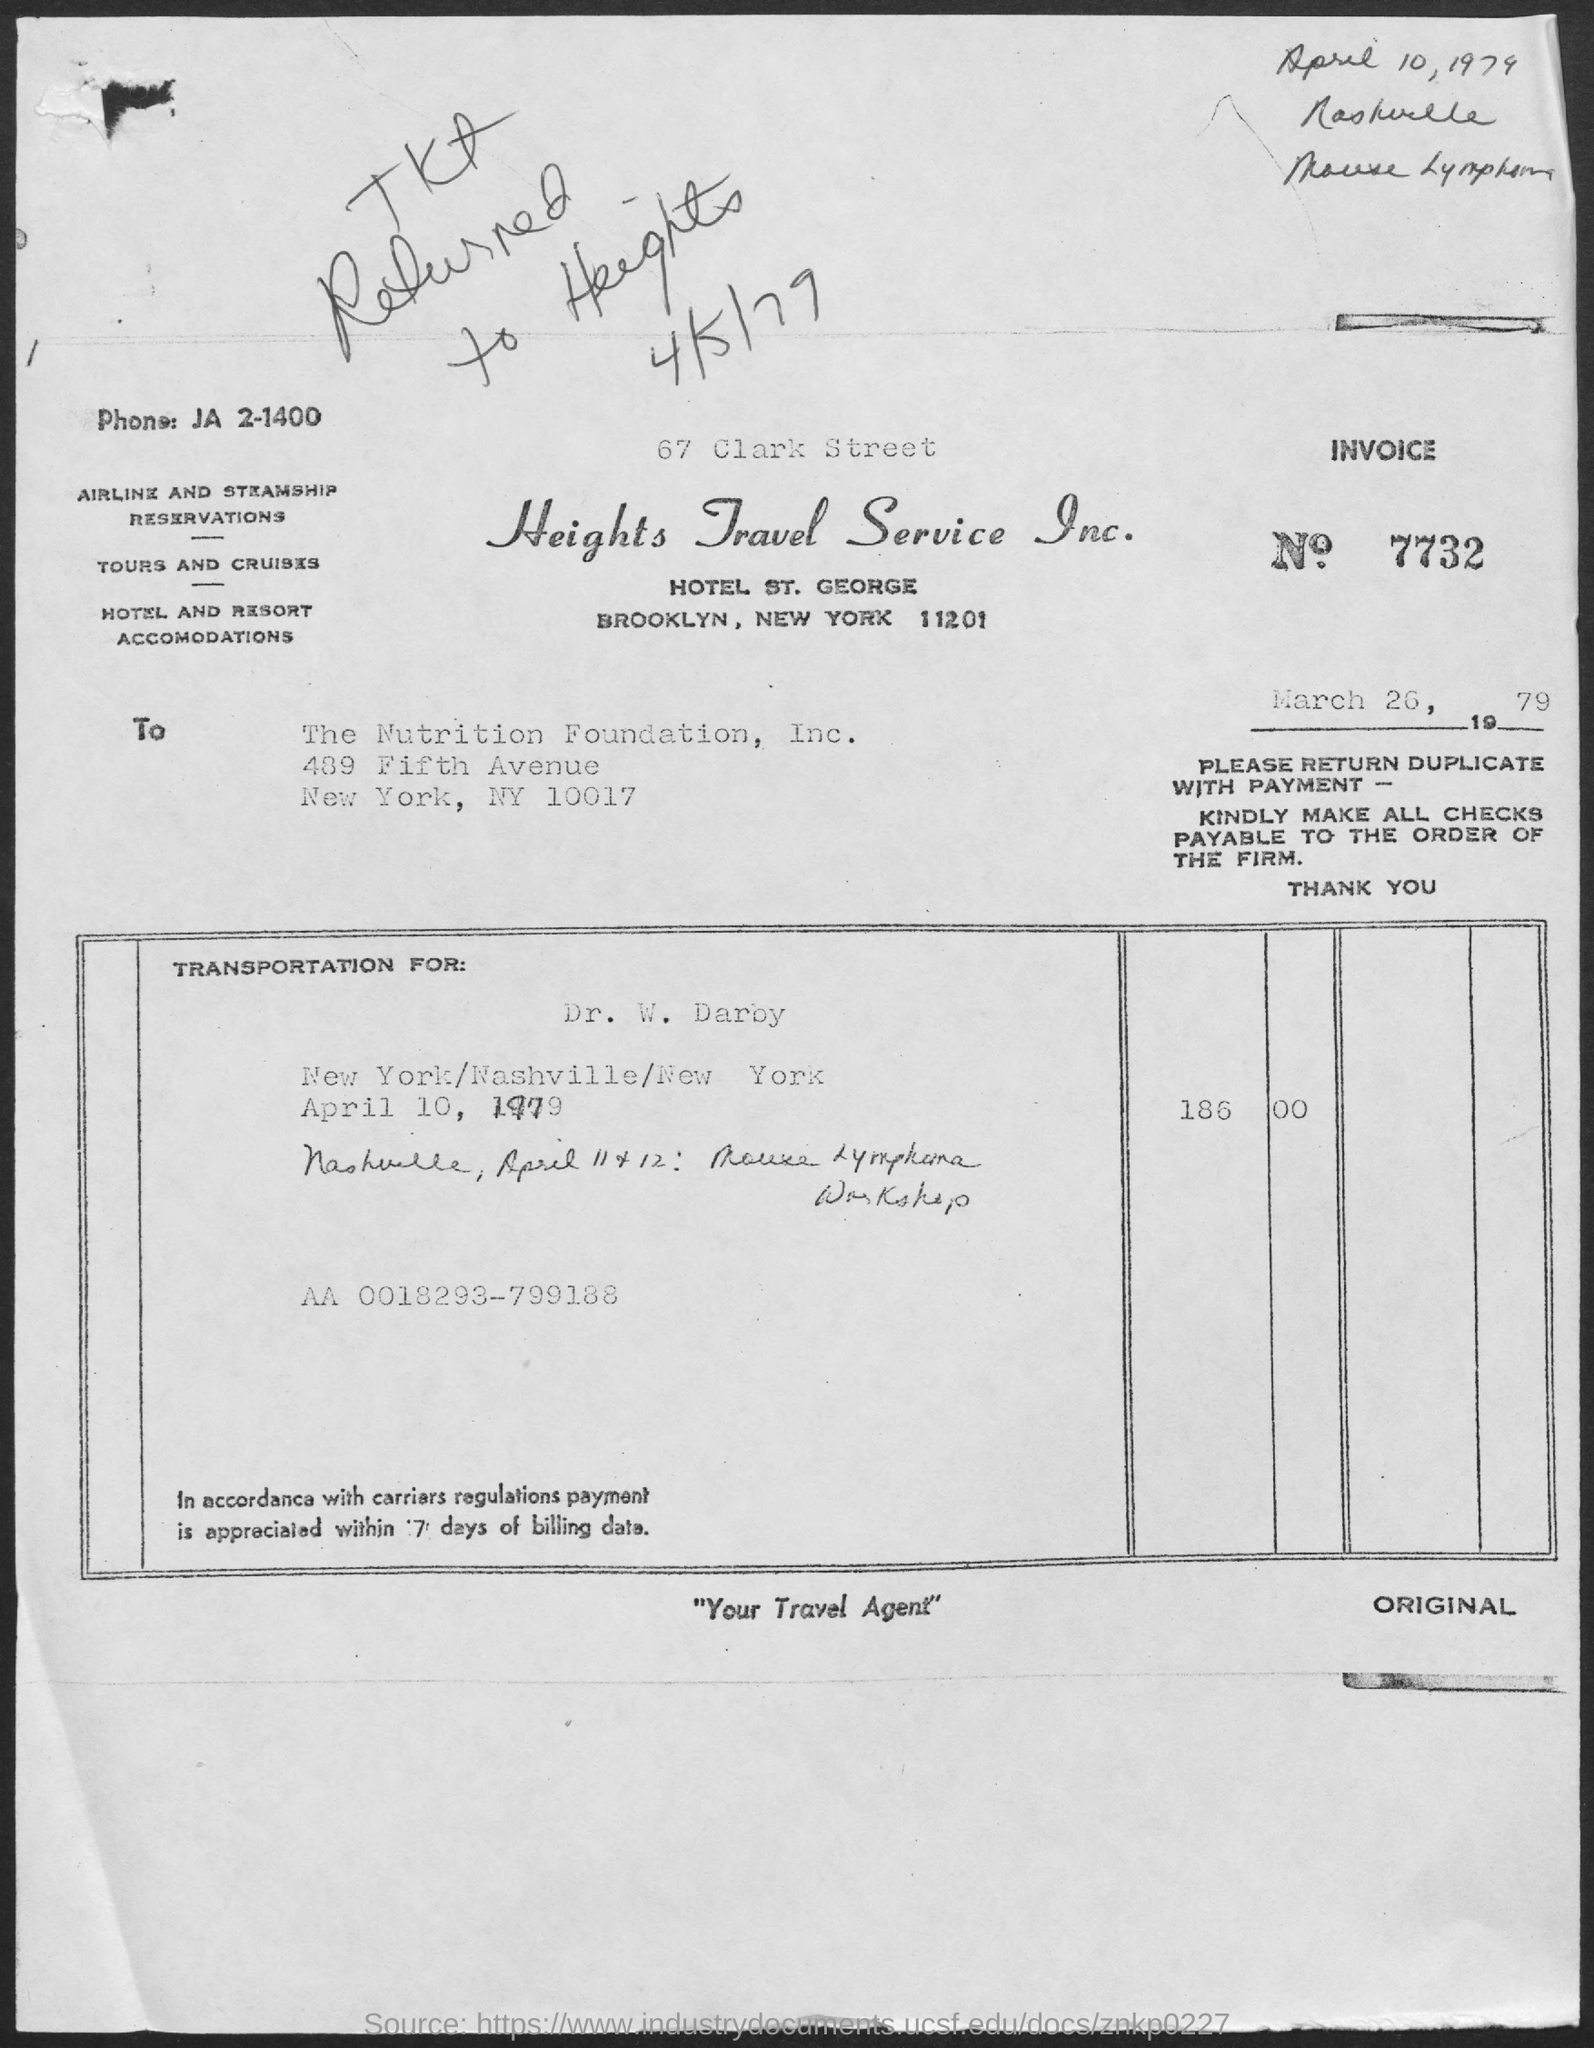List a handful of essential elements in this visual. The invoice number is 7732... Heights Travel Service Inc." is the name of a travel service. 